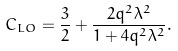<formula> <loc_0><loc_0><loc_500><loc_500>C _ { L O } = \frac { 3 } { 2 } + \frac { 2 q ^ { 2 } \lambda ^ { 2 } } { 1 + 4 q ^ { 2 } \lambda ^ { 2 } } .</formula> 